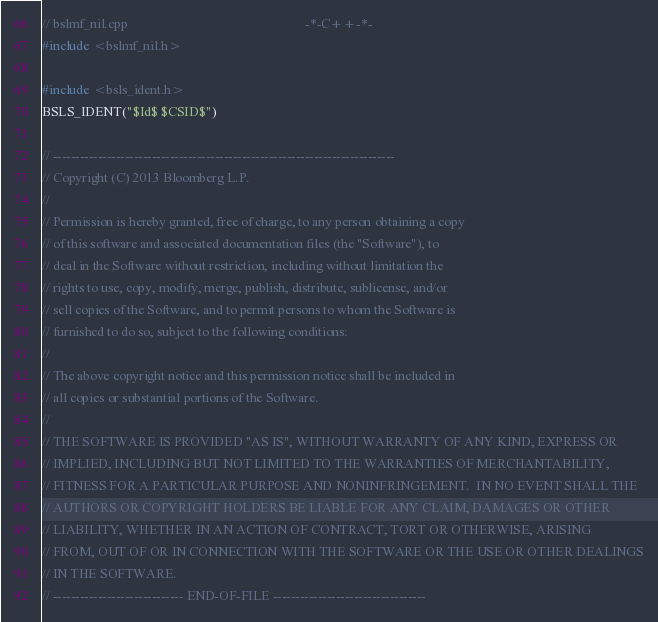<code> <loc_0><loc_0><loc_500><loc_500><_C++_>// bslmf_nil.cpp                                                      -*-C++-*-
#include <bslmf_nil.h>

#include <bsls_ident.h>
BSLS_IDENT("$Id$ $CSID$")

// ----------------------------------------------------------------------------
// Copyright (C) 2013 Bloomberg L.P.
//
// Permission is hereby granted, free of charge, to any person obtaining a copy
// of this software and associated documentation files (the "Software"), to
// deal in the Software without restriction, including without limitation the
// rights to use, copy, modify, merge, publish, distribute, sublicense, and/or
// sell copies of the Software, and to permit persons to whom the Software is
// furnished to do so, subject to the following conditions:
//
// The above copyright notice and this permission notice shall be included in
// all copies or substantial portions of the Software.
//
// THE SOFTWARE IS PROVIDED "AS IS", WITHOUT WARRANTY OF ANY KIND, EXPRESS OR
// IMPLIED, INCLUDING BUT NOT LIMITED TO THE WARRANTIES OF MERCHANTABILITY,
// FITNESS FOR A PARTICULAR PURPOSE AND NONINFRINGEMENT.  IN NO EVENT SHALL THE
// AUTHORS OR COPYRIGHT HOLDERS BE LIABLE FOR ANY CLAIM, DAMAGES OR OTHER
// LIABILITY, WHETHER IN AN ACTION OF CONTRACT, TORT OR OTHERWISE, ARISING
// FROM, OUT OF OR IN CONNECTION WITH THE SOFTWARE OR THE USE OR OTHER DEALINGS
// IN THE SOFTWARE.
// ----------------------------- END-OF-FILE ----------------------------------
</code> 